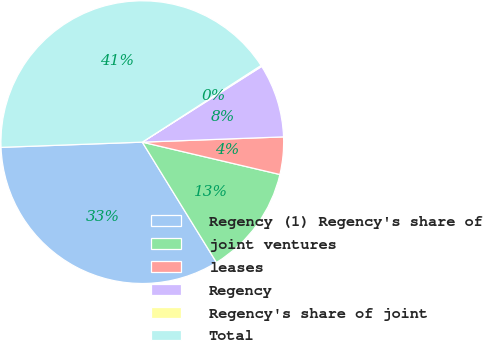<chart> <loc_0><loc_0><loc_500><loc_500><pie_chart><fcel>Regency (1) Regency's share of<fcel>joint ventures<fcel>leases<fcel>Regency<fcel>Regency's share of joint<fcel>Total<nl><fcel>33.2%<fcel>12.53%<fcel>4.27%<fcel>8.4%<fcel>0.13%<fcel>41.46%<nl></chart> 